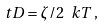<formula> <loc_0><loc_0><loc_500><loc_500>\ t D = \zeta / 2 \ k T \, ,</formula> 